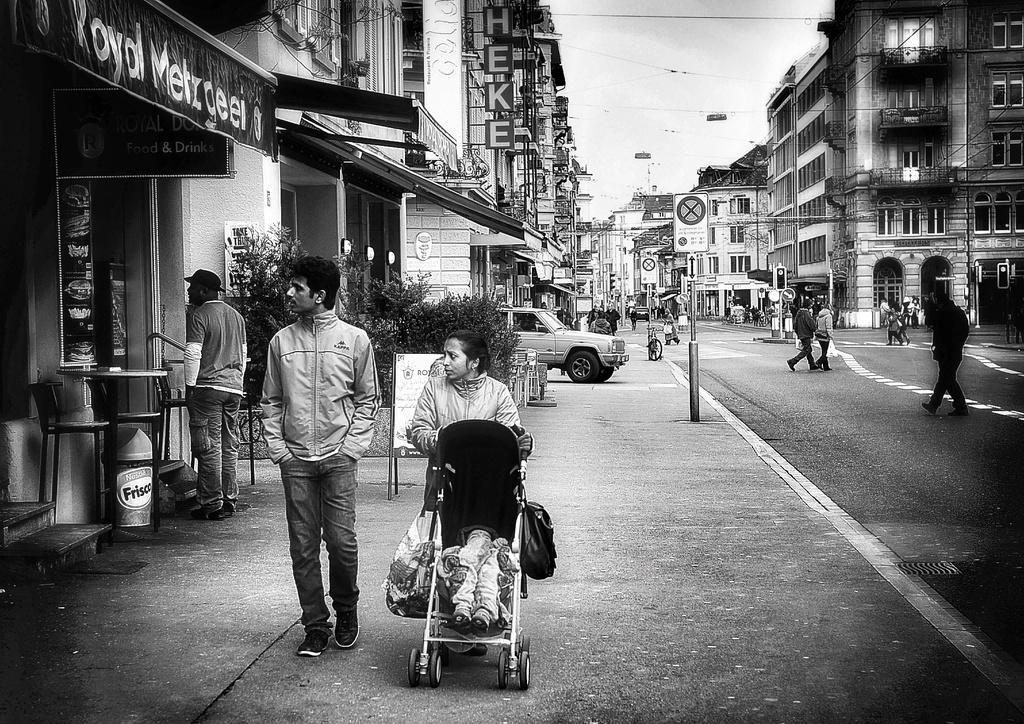In one or two sentences, can you explain what this image depicts? In the picture I can see people are walking on the ground. In the background I can see vehicles, bicycles, traffic lights, sign boards, buildings, wires, plants, poles and the sky. This picture is black and white and color. 